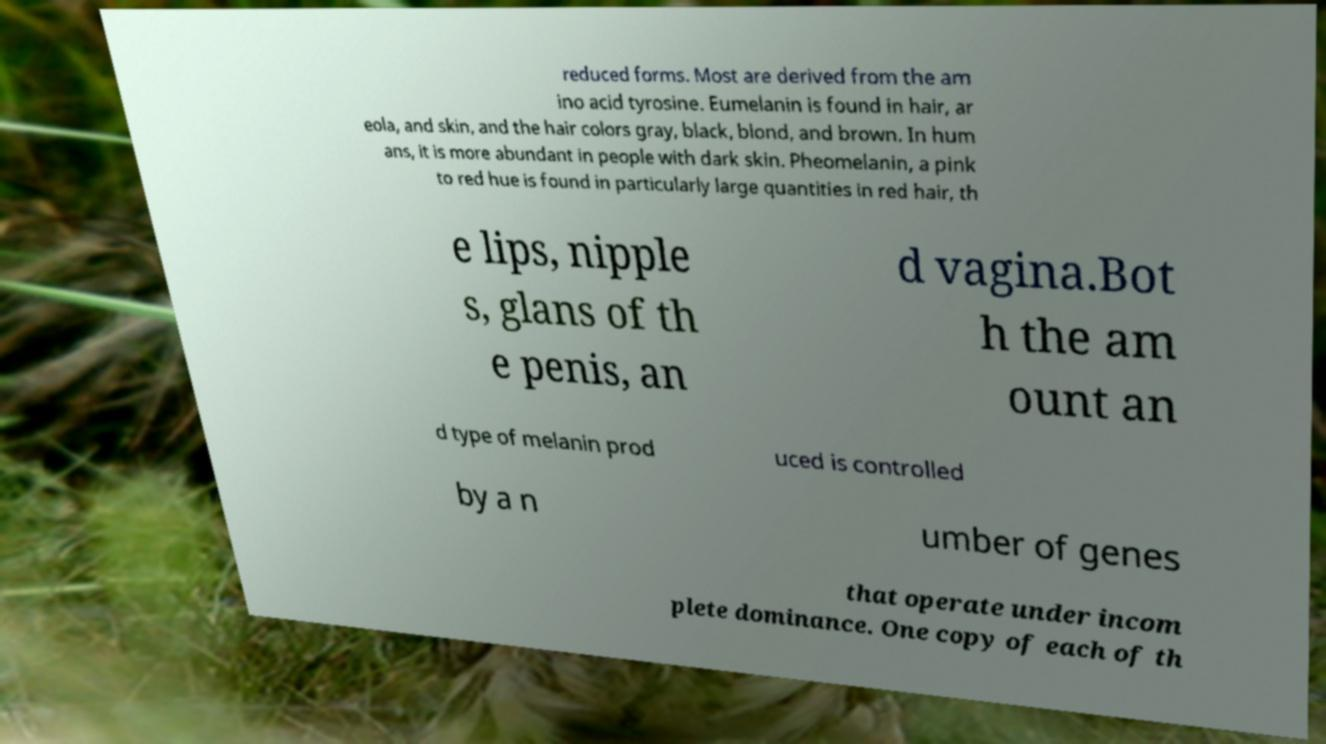There's text embedded in this image that I need extracted. Can you transcribe it verbatim? reduced forms. Most are derived from the am ino acid tyrosine. Eumelanin is found in hair, ar eola, and skin, and the hair colors gray, black, blond, and brown. In hum ans, it is more abundant in people with dark skin. Pheomelanin, a pink to red hue is found in particularly large quantities in red hair, th e lips, nipple s, glans of th e penis, an d vagina.Bot h the am ount an d type of melanin prod uced is controlled by a n umber of genes that operate under incom plete dominance. One copy of each of th 